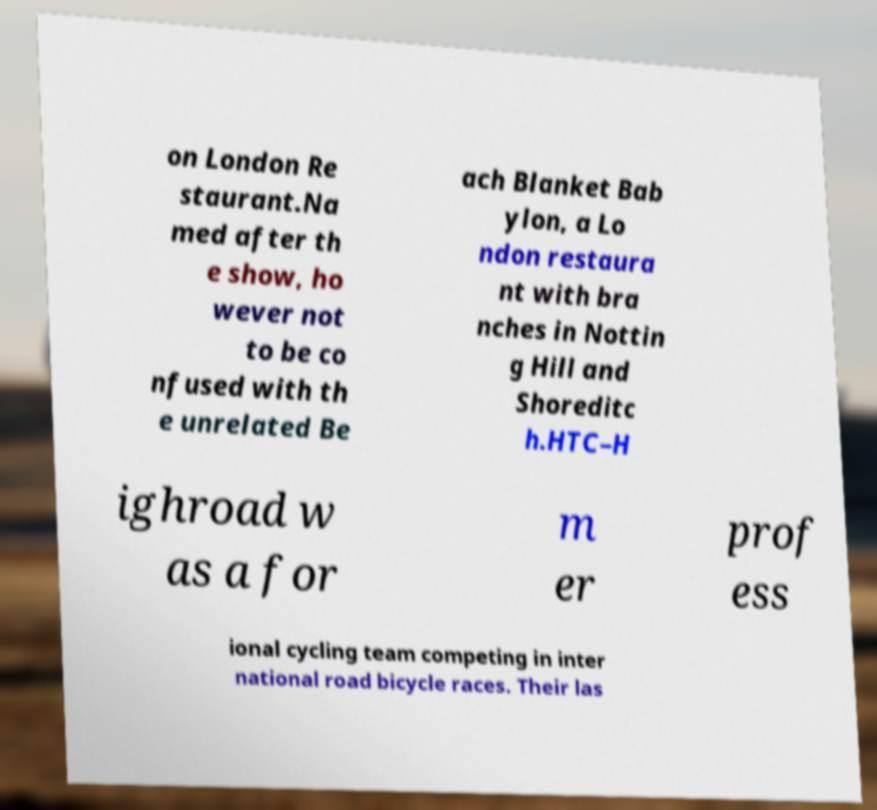What messages or text are displayed in this image? I need them in a readable, typed format. on London Re staurant.Na med after th e show, ho wever not to be co nfused with th e unrelated Be ach Blanket Bab ylon, a Lo ndon restaura nt with bra nches in Nottin g Hill and Shoreditc h.HTC–H ighroad w as a for m er prof ess ional cycling team competing in inter national road bicycle races. Their las 